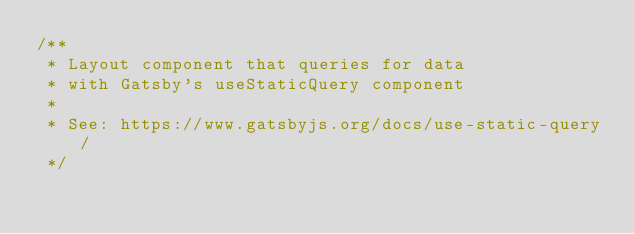Convert code to text. <code><loc_0><loc_0><loc_500><loc_500><_JavaScript_>/**
 * Layout component that queries for data
 * with Gatsby's useStaticQuery component
 *
 * See: https://www.gatsbyjs.org/docs/use-static-query/
 */
</code> 